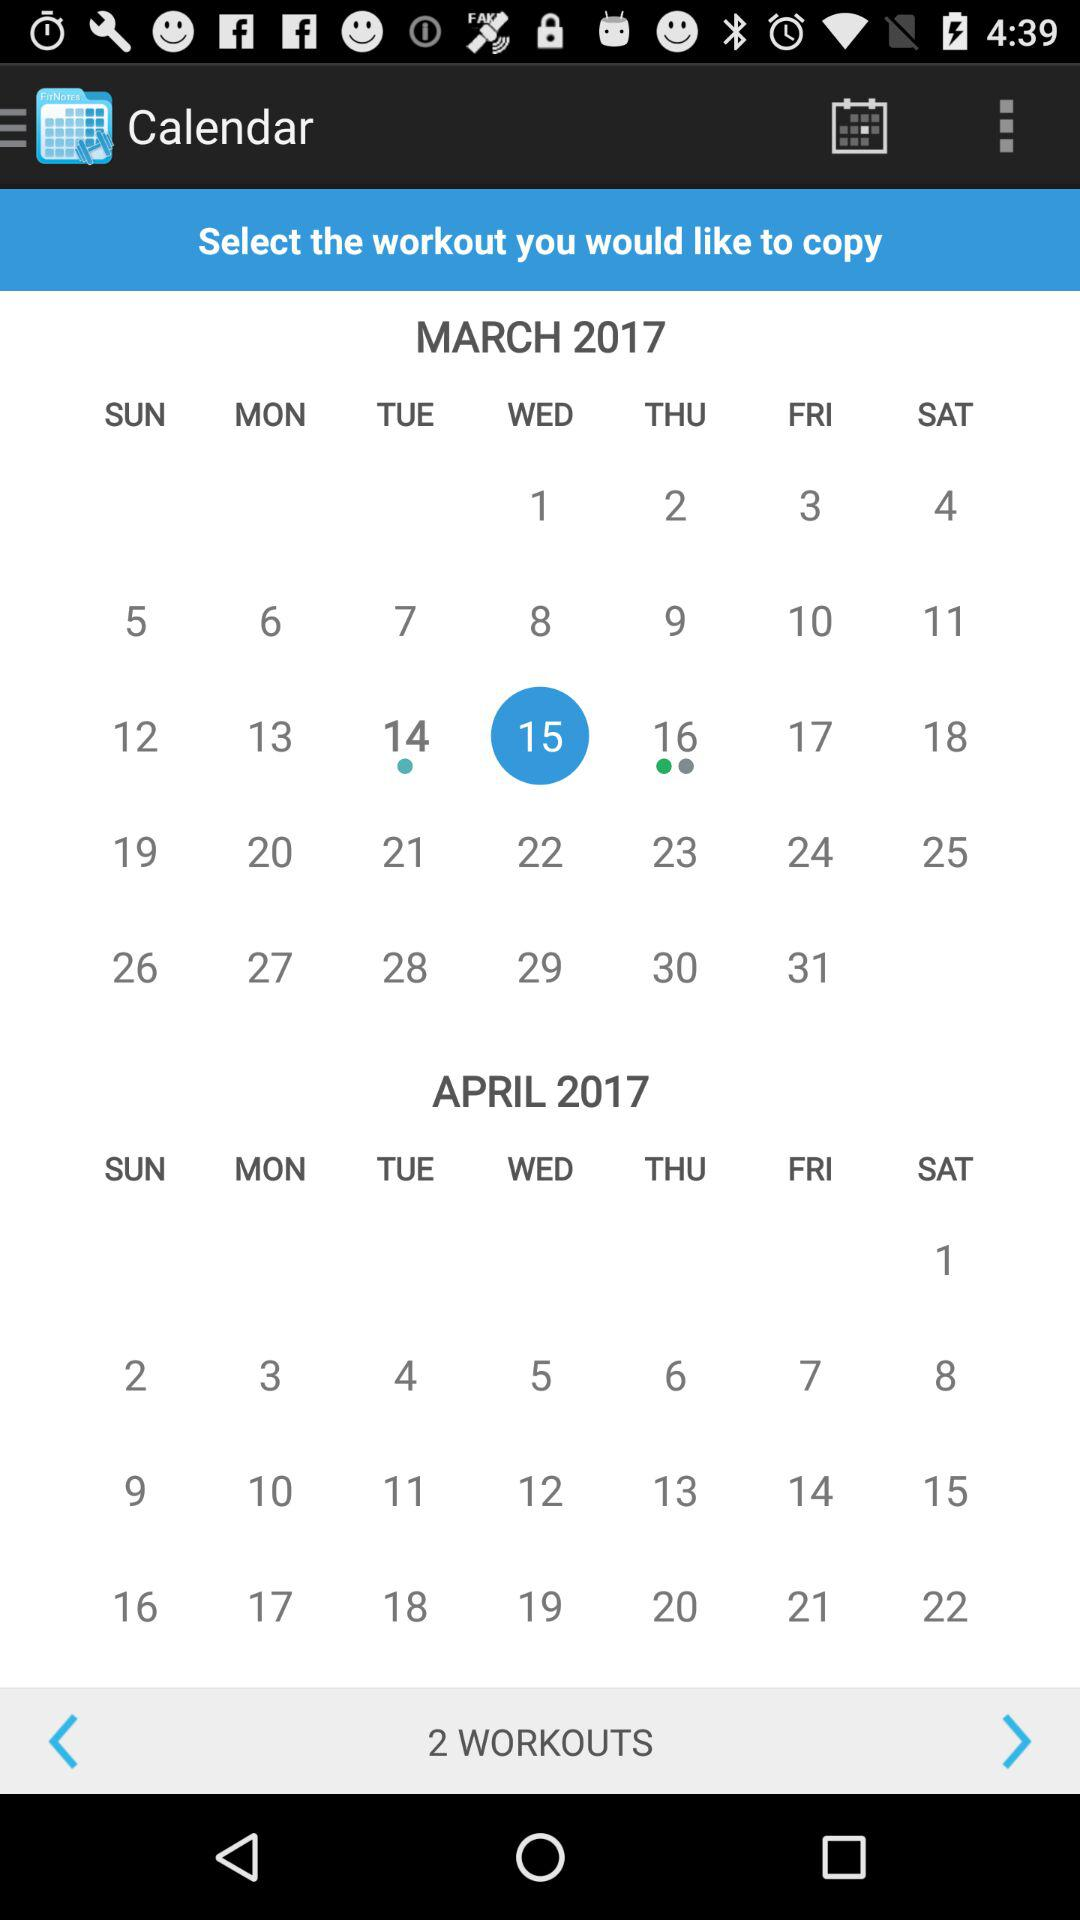What is the day on March 15? The day is Wednesday. 